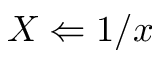<formula> <loc_0><loc_0><loc_500><loc_500>X \Leftarrow 1 / x</formula> 